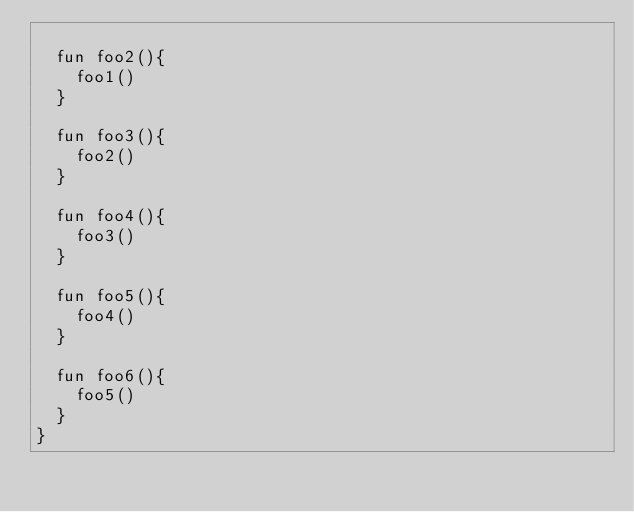Convert code to text. <code><loc_0><loc_0><loc_500><loc_500><_Kotlin_>
  fun foo2(){
    foo1()
  }

  fun foo3(){
    foo2()
  }

  fun foo4(){
    foo3()
  }

  fun foo5(){
    foo4()
  }

  fun foo6(){
    foo5()
  }
}</code> 